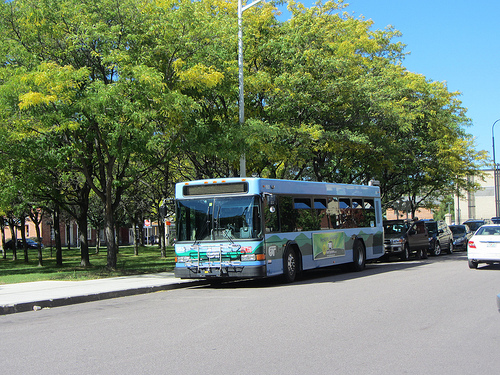How could this image change with different seasons? In spring, the image would be filled with blooming flowers and vivid greenery around the bus and trees, bringing a fresh and energetic aura. Birds would be singing, and the air would carry a sense of renewal and growth. Summer would amplify this brightness with a more intense blue sky, and perhaps people in light clothing enjoying the outdoors. Fall would transform the scene into a tapestry of warm yellows, oranges, and reds, with fallen leaves decorating the sidewalk and road, adding a nostalgic and cozy feel. Winter could blanket the area in snow, creating a serene, calm, almost magical landscape with the bus standing out against the white background, and potential holiday decorations adding festive cheer. 